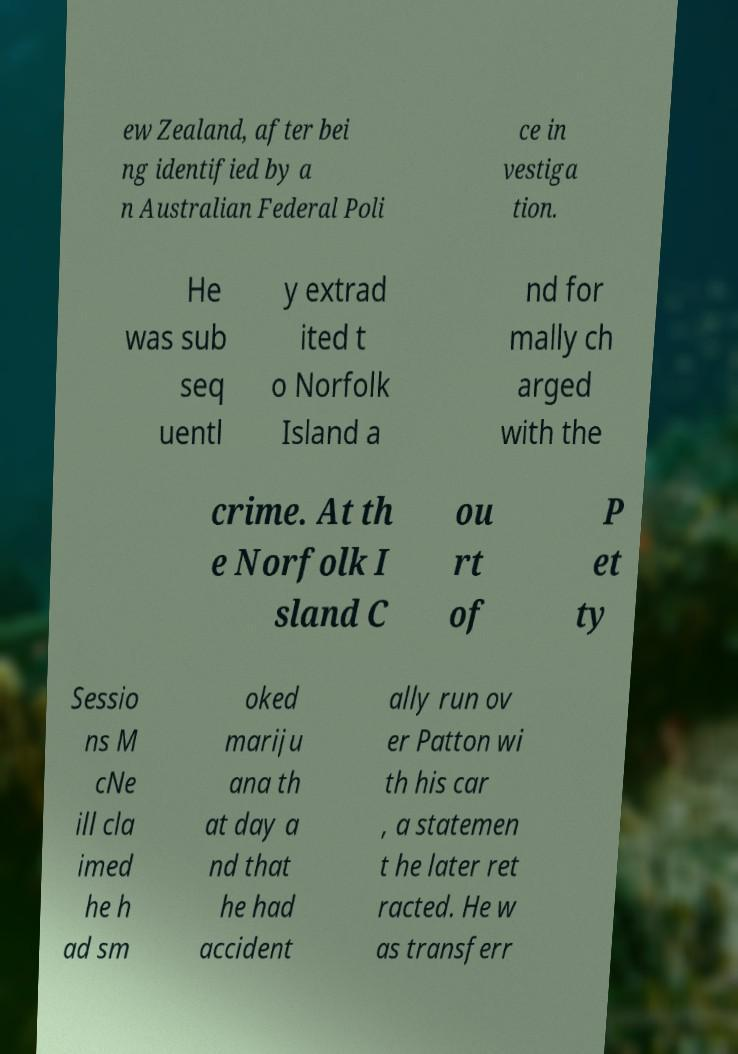There's text embedded in this image that I need extracted. Can you transcribe it verbatim? ew Zealand, after bei ng identified by a n Australian Federal Poli ce in vestiga tion. He was sub seq uentl y extrad ited t o Norfolk Island a nd for mally ch arged with the crime. At th e Norfolk I sland C ou rt of P et ty Sessio ns M cNe ill cla imed he h ad sm oked mariju ana th at day a nd that he had accident ally run ov er Patton wi th his car , a statemen t he later ret racted. He w as transferr 